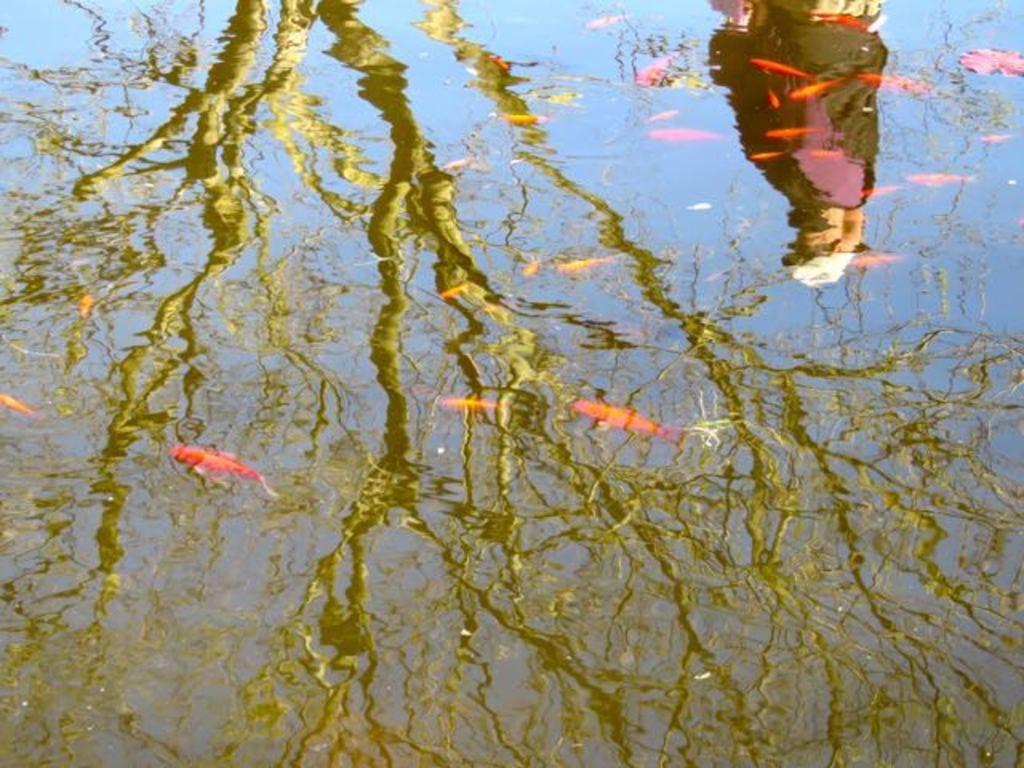What is present in the image? There is water in the image. What can be seen in the reflection of the water? Trees and a person are visible in the reflection of the water. How many pies are floating in the water in the image? There are no pies present in the water in the image. What type of cub is visible in the reflection of the water? There is no cub present in the image, let alone in the reflection of the water. 